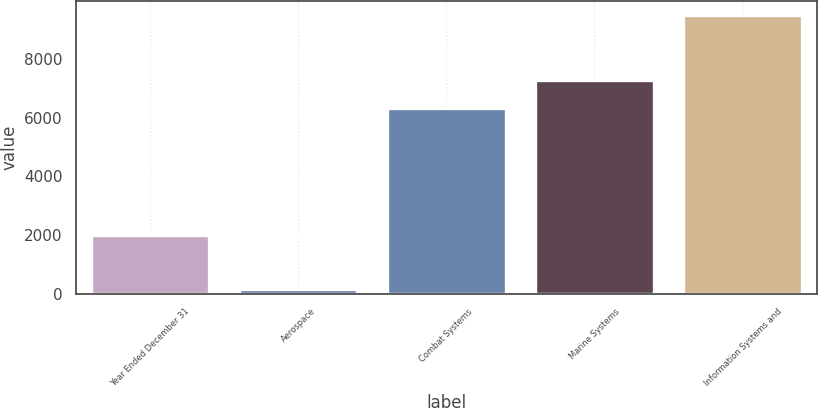<chart> <loc_0><loc_0><loc_500><loc_500><bar_chart><fcel>Year Ended December 31<fcel>Aerospace<fcel>Combat Systems<fcel>Marine Systems<fcel>Information Systems and<nl><fcel>2011<fcel>171<fcel>6343<fcel>7276.6<fcel>9507<nl></chart> 